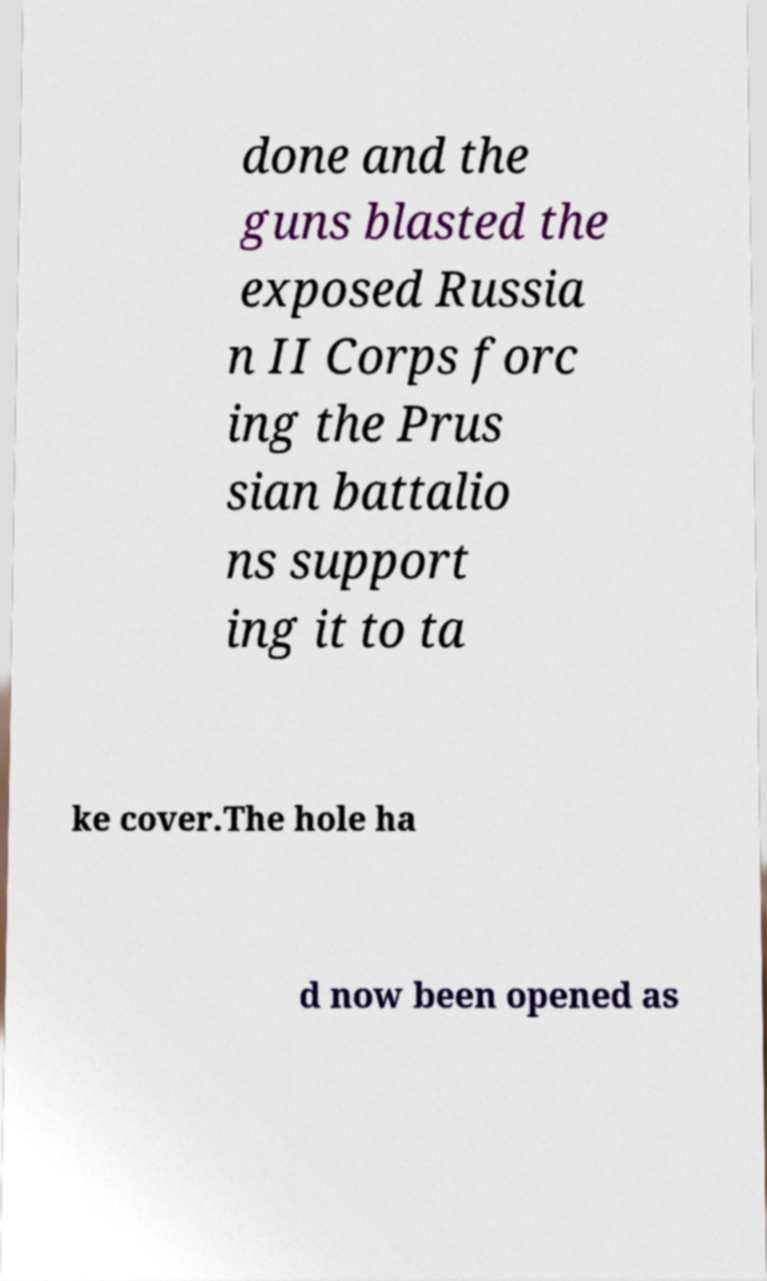Could you extract and type out the text from this image? done and the guns blasted the exposed Russia n II Corps forc ing the Prus sian battalio ns support ing it to ta ke cover.The hole ha d now been opened as 